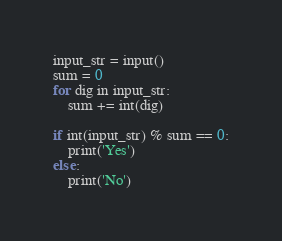<code> <loc_0><loc_0><loc_500><loc_500><_Python_>input_str = input()
sum = 0
for dig in input_str:
    sum += int(dig)

if int(input_str) % sum == 0:
    print('Yes')
else:
    print('No')</code> 